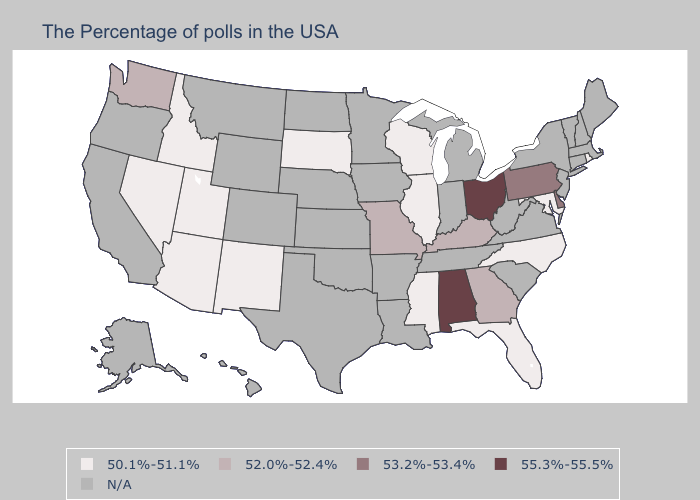Which states have the lowest value in the Northeast?
Short answer required. Rhode Island. Name the states that have a value in the range 50.1%-51.1%?
Answer briefly. Rhode Island, Maryland, North Carolina, Florida, Wisconsin, Illinois, Mississippi, South Dakota, New Mexico, Utah, Arizona, Idaho, Nevada. What is the lowest value in the Northeast?
Quick response, please. 50.1%-51.1%. Name the states that have a value in the range 50.1%-51.1%?
Quick response, please. Rhode Island, Maryland, North Carolina, Florida, Wisconsin, Illinois, Mississippi, South Dakota, New Mexico, Utah, Arizona, Idaho, Nevada. Name the states that have a value in the range 52.0%-52.4%?
Give a very brief answer. Georgia, Kentucky, Missouri, Washington. What is the value of Virginia?
Short answer required. N/A. What is the value of Alaska?
Be succinct. N/A. What is the value of Louisiana?
Quick response, please. N/A. Which states have the lowest value in the USA?
Answer briefly. Rhode Island, Maryland, North Carolina, Florida, Wisconsin, Illinois, Mississippi, South Dakota, New Mexico, Utah, Arizona, Idaho, Nevada. Name the states that have a value in the range 55.3%-55.5%?
Give a very brief answer. Ohio, Alabama. What is the value of South Carolina?
Concise answer only. N/A. What is the value of Mississippi?
Concise answer only. 50.1%-51.1%. What is the highest value in the USA?
Answer briefly. 55.3%-55.5%. What is the value of South Dakota?
Quick response, please. 50.1%-51.1%. 